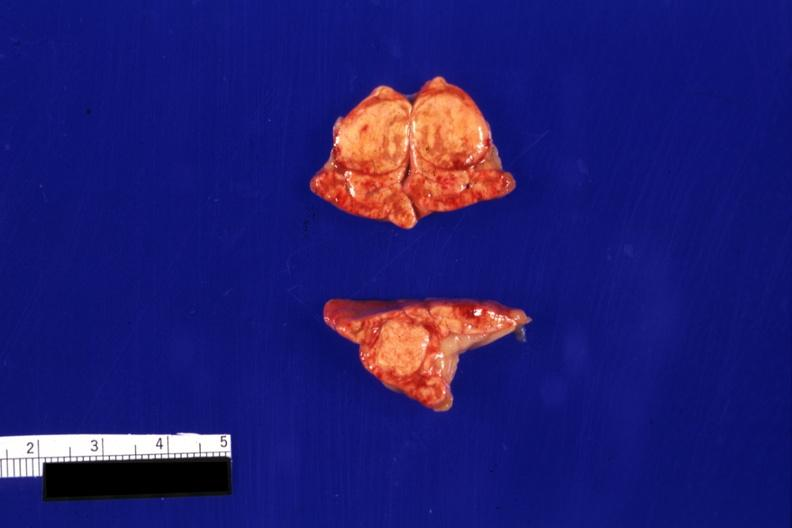what is present?
Answer the question using a single word or phrase. Endocrine 